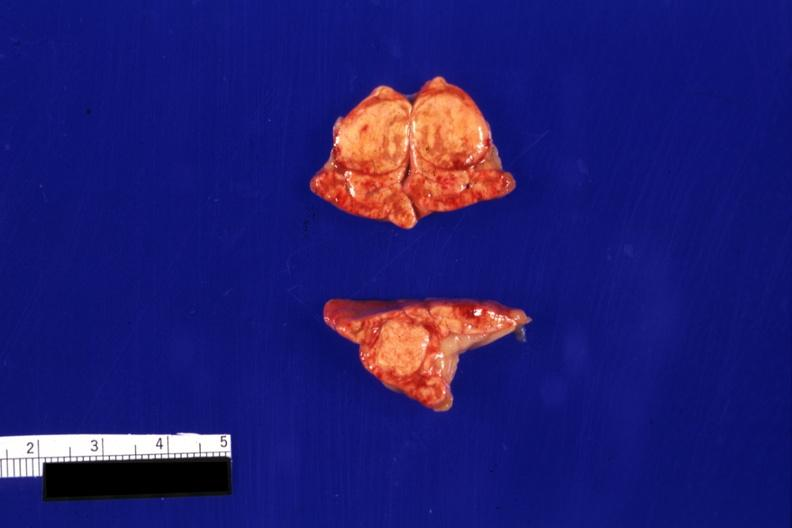what is present?
Answer the question using a single word or phrase. Endocrine 